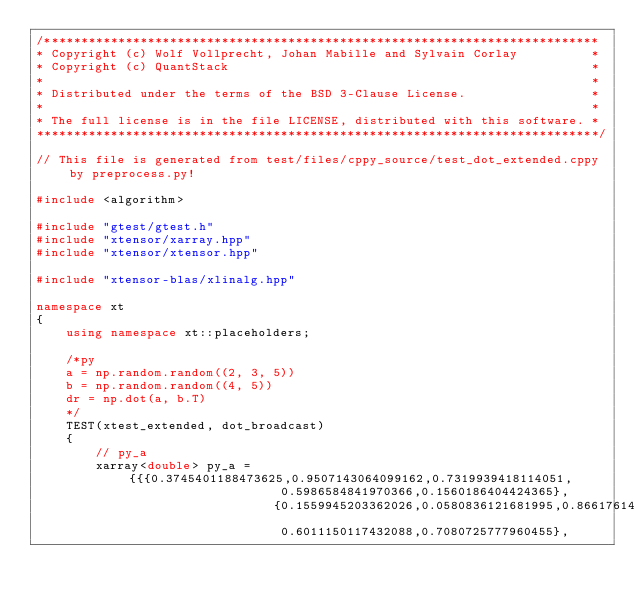<code> <loc_0><loc_0><loc_500><loc_500><_C++_>/***************************************************************************
* Copyright (c) Wolf Vollprecht, Johan Mabille and Sylvain Corlay          *
* Copyright (c) QuantStack                                                 *
*                                                                          *
* Distributed under the terms of the BSD 3-Clause License.                 *
*                                                                          *
* The full license is in the file LICENSE, distributed with this software. *
****************************************************************************/

// This file is generated from test/files/cppy_source/test_dot_extended.cppy by preprocess.py!

#include <algorithm>

#include "gtest/gtest.h"
#include "xtensor/xarray.hpp"
#include "xtensor/xtensor.hpp"

#include "xtensor-blas/xlinalg.hpp"

namespace xt
{
    using namespace xt::placeholders;

    /*py
    a = np.random.random((2, 3, 5))
    b = np.random.random((4, 5))
    dr = np.dot(a, b.T)
    */
    TEST(xtest_extended, dot_broadcast)
    {
        // py_a
        xarray<double> py_a = {{{0.3745401188473625,0.9507143064099162,0.7319939418114051,
                                 0.5986584841970366,0.1560186404424365},
                                {0.1559945203362026,0.0580836121681995,0.8661761457749352,
                                 0.6011150117432088,0.7080725777960455},</code> 